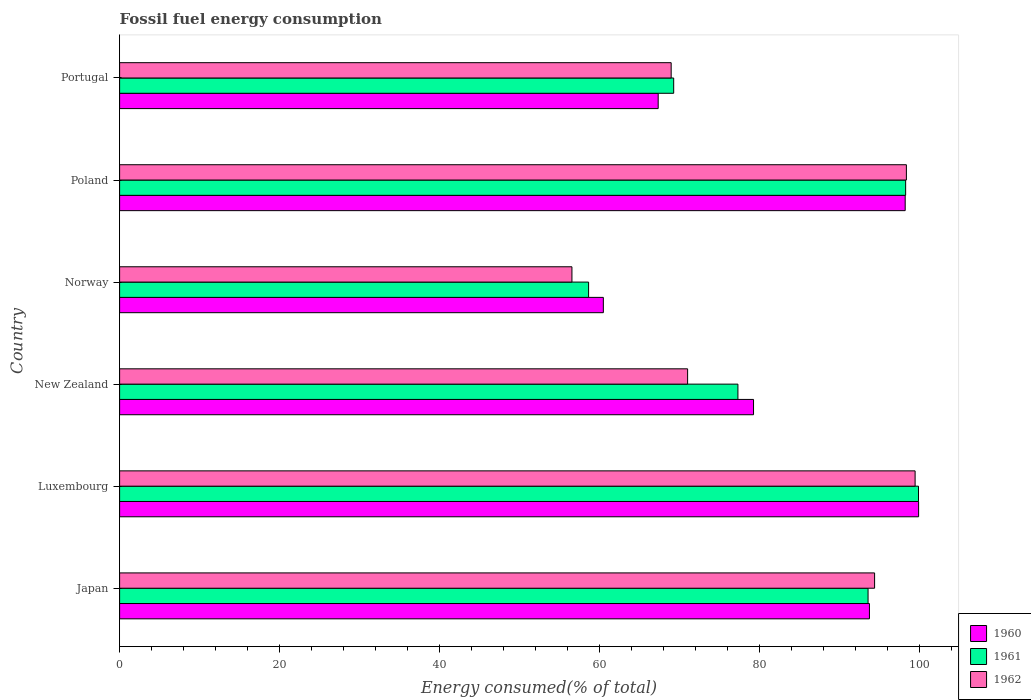How many groups of bars are there?
Offer a terse response. 6. Are the number of bars on each tick of the Y-axis equal?
Offer a terse response. Yes. How many bars are there on the 1st tick from the top?
Ensure brevity in your answer.  3. What is the label of the 1st group of bars from the top?
Your response must be concise. Portugal. What is the percentage of energy consumed in 1961 in Luxembourg?
Ensure brevity in your answer.  99.91. Across all countries, what is the maximum percentage of energy consumed in 1962?
Offer a terse response. 99.49. Across all countries, what is the minimum percentage of energy consumed in 1961?
Offer a very short reply. 58.65. In which country was the percentage of energy consumed in 1962 maximum?
Your response must be concise. Luxembourg. What is the total percentage of energy consumed in 1962 in the graph?
Make the answer very short. 488.89. What is the difference between the percentage of energy consumed in 1960 in Japan and that in Norway?
Offer a terse response. 33.28. What is the difference between the percentage of energy consumed in 1962 in New Zealand and the percentage of energy consumed in 1961 in Poland?
Provide a succinct answer. -27.27. What is the average percentage of energy consumed in 1962 per country?
Give a very brief answer. 81.48. What is the difference between the percentage of energy consumed in 1961 and percentage of energy consumed in 1960 in Portugal?
Your response must be concise. 1.94. In how many countries, is the percentage of energy consumed in 1961 greater than 16 %?
Provide a succinct answer. 6. What is the ratio of the percentage of energy consumed in 1960 in New Zealand to that in Norway?
Offer a very short reply. 1.31. Is the percentage of energy consumed in 1960 in New Zealand less than that in Poland?
Ensure brevity in your answer.  Yes. What is the difference between the highest and the second highest percentage of energy consumed in 1962?
Your answer should be compact. 1.09. What is the difference between the highest and the lowest percentage of energy consumed in 1960?
Your answer should be compact. 39.43. In how many countries, is the percentage of energy consumed in 1961 greater than the average percentage of energy consumed in 1961 taken over all countries?
Ensure brevity in your answer.  3. Is the sum of the percentage of energy consumed in 1960 in Japan and Portugal greater than the maximum percentage of energy consumed in 1962 across all countries?
Your answer should be compact. Yes. What does the 2nd bar from the top in Japan represents?
Keep it short and to the point. 1961. How many countries are there in the graph?
Ensure brevity in your answer.  6. Does the graph contain any zero values?
Offer a terse response. No. Does the graph contain grids?
Your answer should be very brief. No. How many legend labels are there?
Provide a short and direct response. 3. What is the title of the graph?
Your response must be concise. Fossil fuel energy consumption. What is the label or title of the X-axis?
Provide a short and direct response. Energy consumed(% of total). What is the Energy consumed(% of total) in 1960 in Japan?
Your answer should be very brief. 93.78. What is the Energy consumed(% of total) in 1961 in Japan?
Make the answer very short. 93.6. What is the Energy consumed(% of total) in 1962 in Japan?
Ensure brevity in your answer.  94.42. What is the Energy consumed(% of total) of 1960 in Luxembourg?
Ensure brevity in your answer.  99.92. What is the Energy consumed(% of total) in 1961 in Luxembourg?
Your response must be concise. 99.91. What is the Energy consumed(% of total) in 1962 in Luxembourg?
Make the answer very short. 99.49. What is the Energy consumed(% of total) in 1960 in New Zealand?
Offer a terse response. 79.28. What is the Energy consumed(% of total) of 1961 in New Zealand?
Offer a terse response. 77.33. What is the Energy consumed(% of total) in 1962 in New Zealand?
Provide a succinct answer. 71.04. What is the Energy consumed(% of total) of 1960 in Norway?
Ensure brevity in your answer.  60.5. What is the Energy consumed(% of total) of 1961 in Norway?
Provide a succinct answer. 58.65. What is the Energy consumed(% of total) in 1962 in Norway?
Give a very brief answer. 56.57. What is the Energy consumed(% of total) in 1960 in Poland?
Your answer should be very brief. 98.25. What is the Energy consumed(% of total) of 1961 in Poland?
Your answer should be compact. 98.3. What is the Energy consumed(% of total) of 1962 in Poland?
Offer a very short reply. 98.4. What is the Energy consumed(% of total) of 1960 in Portugal?
Provide a short and direct response. 67.36. What is the Energy consumed(% of total) in 1961 in Portugal?
Make the answer very short. 69.3. What is the Energy consumed(% of total) in 1962 in Portugal?
Give a very brief answer. 68.98. Across all countries, what is the maximum Energy consumed(% of total) in 1960?
Provide a succinct answer. 99.92. Across all countries, what is the maximum Energy consumed(% of total) in 1961?
Make the answer very short. 99.91. Across all countries, what is the maximum Energy consumed(% of total) of 1962?
Keep it short and to the point. 99.49. Across all countries, what is the minimum Energy consumed(% of total) of 1960?
Ensure brevity in your answer.  60.5. Across all countries, what is the minimum Energy consumed(% of total) in 1961?
Your response must be concise. 58.65. Across all countries, what is the minimum Energy consumed(% of total) in 1962?
Offer a very short reply. 56.57. What is the total Energy consumed(% of total) in 1960 in the graph?
Keep it short and to the point. 499.08. What is the total Energy consumed(% of total) of 1961 in the graph?
Give a very brief answer. 497.09. What is the total Energy consumed(% of total) of 1962 in the graph?
Provide a succinct answer. 488.89. What is the difference between the Energy consumed(% of total) of 1960 in Japan and that in Luxembourg?
Make the answer very short. -6.15. What is the difference between the Energy consumed(% of total) in 1961 in Japan and that in Luxembourg?
Offer a terse response. -6.31. What is the difference between the Energy consumed(% of total) of 1962 in Japan and that in Luxembourg?
Provide a short and direct response. -5.07. What is the difference between the Energy consumed(% of total) of 1960 in Japan and that in New Zealand?
Make the answer very short. 14.5. What is the difference between the Energy consumed(% of total) in 1961 in Japan and that in New Zealand?
Ensure brevity in your answer.  16.28. What is the difference between the Energy consumed(% of total) in 1962 in Japan and that in New Zealand?
Your answer should be compact. 23.38. What is the difference between the Energy consumed(% of total) of 1960 in Japan and that in Norway?
Your answer should be compact. 33.28. What is the difference between the Energy consumed(% of total) in 1961 in Japan and that in Norway?
Make the answer very short. 34.95. What is the difference between the Energy consumed(% of total) in 1962 in Japan and that in Norway?
Provide a short and direct response. 37.85. What is the difference between the Energy consumed(% of total) of 1960 in Japan and that in Poland?
Ensure brevity in your answer.  -4.47. What is the difference between the Energy consumed(% of total) in 1961 in Japan and that in Poland?
Your answer should be very brief. -4.7. What is the difference between the Energy consumed(% of total) of 1962 in Japan and that in Poland?
Your response must be concise. -3.98. What is the difference between the Energy consumed(% of total) in 1960 in Japan and that in Portugal?
Offer a terse response. 26.42. What is the difference between the Energy consumed(% of total) of 1961 in Japan and that in Portugal?
Provide a short and direct response. 24.31. What is the difference between the Energy consumed(% of total) of 1962 in Japan and that in Portugal?
Offer a very short reply. 25.44. What is the difference between the Energy consumed(% of total) of 1960 in Luxembourg and that in New Zealand?
Keep it short and to the point. 20.65. What is the difference between the Energy consumed(% of total) of 1961 in Luxembourg and that in New Zealand?
Your answer should be very brief. 22.58. What is the difference between the Energy consumed(% of total) of 1962 in Luxembourg and that in New Zealand?
Your response must be concise. 28.45. What is the difference between the Energy consumed(% of total) of 1960 in Luxembourg and that in Norway?
Make the answer very short. 39.43. What is the difference between the Energy consumed(% of total) of 1961 in Luxembourg and that in Norway?
Provide a succinct answer. 41.26. What is the difference between the Energy consumed(% of total) in 1962 in Luxembourg and that in Norway?
Keep it short and to the point. 42.92. What is the difference between the Energy consumed(% of total) in 1960 in Luxembourg and that in Poland?
Ensure brevity in your answer.  1.68. What is the difference between the Energy consumed(% of total) in 1961 in Luxembourg and that in Poland?
Ensure brevity in your answer.  1.61. What is the difference between the Energy consumed(% of total) of 1962 in Luxembourg and that in Poland?
Ensure brevity in your answer.  1.09. What is the difference between the Energy consumed(% of total) of 1960 in Luxembourg and that in Portugal?
Make the answer very short. 32.57. What is the difference between the Energy consumed(% of total) in 1961 in Luxembourg and that in Portugal?
Keep it short and to the point. 30.62. What is the difference between the Energy consumed(% of total) in 1962 in Luxembourg and that in Portugal?
Give a very brief answer. 30.51. What is the difference between the Energy consumed(% of total) of 1960 in New Zealand and that in Norway?
Your answer should be very brief. 18.78. What is the difference between the Energy consumed(% of total) in 1961 in New Zealand and that in Norway?
Keep it short and to the point. 18.68. What is the difference between the Energy consumed(% of total) of 1962 in New Zealand and that in Norway?
Ensure brevity in your answer.  14.47. What is the difference between the Energy consumed(% of total) in 1960 in New Zealand and that in Poland?
Your answer should be very brief. -18.97. What is the difference between the Energy consumed(% of total) of 1961 in New Zealand and that in Poland?
Ensure brevity in your answer.  -20.98. What is the difference between the Energy consumed(% of total) in 1962 in New Zealand and that in Poland?
Offer a terse response. -27.36. What is the difference between the Energy consumed(% of total) in 1960 in New Zealand and that in Portugal?
Make the answer very short. 11.92. What is the difference between the Energy consumed(% of total) of 1961 in New Zealand and that in Portugal?
Your answer should be very brief. 8.03. What is the difference between the Energy consumed(% of total) in 1962 in New Zealand and that in Portugal?
Your response must be concise. 2.06. What is the difference between the Energy consumed(% of total) in 1960 in Norway and that in Poland?
Provide a short and direct response. -37.75. What is the difference between the Energy consumed(% of total) in 1961 in Norway and that in Poland?
Provide a succinct answer. -39.65. What is the difference between the Energy consumed(% of total) in 1962 in Norway and that in Poland?
Your answer should be compact. -41.83. What is the difference between the Energy consumed(% of total) of 1960 in Norway and that in Portugal?
Offer a very short reply. -6.86. What is the difference between the Energy consumed(% of total) of 1961 in Norway and that in Portugal?
Provide a short and direct response. -10.64. What is the difference between the Energy consumed(% of total) of 1962 in Norway and that in Portugal?
Offer a very short reply. -12.41. What is the difference between the Energy consumed(% of total) of 1960 in Poland and that in Portugal?
Your answer should be very brief. 30.89. What is the difference between the Energy consumed(% of total) in 1961 in Poland and that in Portugal?
Provide a short and direct response. 29.01. What is the difference between the Energy consumed(% of total) in 1962 in Poland and that in Portugal?
Offer a very short reply. 29.42. What is the difference between the Energy consumed(% of total) of 1960 in Japan and the Energy consumed(% of total) of 1961 in Luxembourg?
Your answer should be compact. -6.14. What is the difference between the Energy consumed(% of total) of 1960 in Japan and the Energy consumed(% of total) of 1962 in Luxembourg?
Your answer should be compact. -5.71. What is the difference between the Energy consumed(% of total) of 1961 in Japan and the Energy consumed(% of total) of 1962 in Luxembourg?
Offer a terse response. -5.88. What is the difference between the Energy consumed(% of total) of 1960 in Japan and the Energy consumed(% of total) of 1961 in New Zealand?
Give a very brief answer. 16.45. What is the difference between the Energy consumed(% of total) in 1960 in Japan and the Energy consumed(% of total) in 1962 in New Zealand?
Give a very brief answer. 22.74. What is the difference between the Energy consumed(% of total) in 1961 in Japan and the Energy consumed(% of total) in 1962 in New Zealand?
Your answer should be compact. 22.57. What is the difference between the Energy consumed(% of total) of 1960 in Japan and the Energy consumed(% of total) of 1961 in Norway?
Offer a very short reply. 35.12. What is the difference between the Energy consumed(% of total) of 1960 in Japan and the Energy consumed(% of total) of 1962 in Norway?
Provide a short and direct response. 37.21. What is the difference between the Energy consumed(% of total) in 1961 in Japan and the Energy consumed(% of total) in 1962 in Norway?
Offer a terse response. 37.03. What is the difference between the Energy consumed(% of total) of 1960 in Japan and the Energy consumed(% of total) of 1961 in Poland?
Give a very brief answer. -4.53. What is the difference between the Energy consumed(% of total) of 1960 in Japan and the Energy consumed(% of total) of 1962 in Poland?
Give a very brief answer. -4.62. What is the difference between the Energy consumed(% of total) of 1961 in Japan and the Energy consumed(% of total) of 1962 in Poland?
Your answer should be very brief. -4.79. What is the difference between the Energy consumed(% of total) of 1960 in Japan and the Energy consumed(% of total) of 1961 in Portugal?
Offer a very short reply. 24.48. What is the difference between the Energy consumed(% of total) in 1960 in Japan and the Energy consumed(% of total) in 1962 in Portugal?
Your response must be concise. 24.8. What is the difference between the Energy consumed(% of total) of 1961 in Japan and the Energy consumed(% of total) of 1962 in Portugal?
Your response must be concise. 24.62. What is the difference between the Energy consumed(% of total) of 1960 in Luxembourg and the Energy consumed(% of total) of 1961 in New Zealand?
Your answer should be compact. 22.6. What is the difference between the Energy consumed(% of total) of 1960 in Luxembourg and the Energy consumed(% of total) of 1962 in New Zealand?
Your answer should be very brief. 28.89. What is the difference between the Energy consumed(% of total) of 1961 in Luxembourg and the Energy consumed(% of total) of 1962 in New Zealand?
Ensure brevity in your answer.  28.88. What is the difference between the Energy consumed(% of total) of 1960 in Luxembourg and the Energy consumed(% of total) of 1961 in Norway?
Keep it short and to the point. 41.27. What is the difference between the Energy consumed(% of total) in 1960 in Luxembourg and the Energy consumed(% of total) in 1962 in Norway?
Keep it short and to the point. 43.35. What is the difference between the Energy consumed(% of total) of 1961 in Luxembourg and the Energy consumed(% of total) of 1962 in Norway?
Keep it short and to the point. 43.34. What is the difference between the Energy consumed(% of total) of 1960 in Luxembourg and the Energy consumed(% of total) of 1961 in Poland?
Provide a short and direct response. 1.62. What is the difference between the Energy consumed(% of total) of 1960 in Luxembourg and the Energy consumed(% of total) of 1962 in Poland?
Ensure brevity in your answer.  1.53. What is the difference between the Energy consumed(% of total) in 1961 in Luxembourg and the Energy consumed(% of total) in 1962 in Poland?
Offer a terse response. 1.52. What is the difference between the Energy consumed(% of total) of 1960 in Luxembourg and the Energy consumed(% of total) of 1961 in Portugal?
Provide a succinct answer. 30.63. What is the difference between the Energy consumed(% of total) in 1960 in Luxembourg and the Energy consumed(% of total) in 1962 in Portugal?
Provide a succinct answer. 30.95. What is the difference between the Energy consumed(% of total) of 1961 in Luxembourg and the Energy consumed(% of total) of 1962 in Portugal?
Provide a succinct answer. 30.93. What is the difference between the Energy consumed(% of total) in 1960 in New Zealand and the Energy consumed(% of total) in 1961 in Norway?
Make the answer very short. 20.63. What is the difference between the Energy consumed(% of total) of 1960 in New Zealand and the Energy consumed(% of total) of 1962 in Norway?
Offer a terse response. 22.71. What is the difference between the Energy consumed(% of total) in 1961 in New Zealand and the Energy consumed(% of total) in 1962 in Norway?
Keep it short and to the point. 20.76. What is the difference between the Energy consumed(% of total) of 1960 in New Zealand and the Energy consumed(% of total) of 1961 in Poland?
Keep it short and to the point. -19.02. What is the difference between the Energy consumed(% of total) of 1960 in New Zealand and the Energy consumed(% of total) of 1962 in Poland?
Make the answer very short. -19.12. What is the difference between the Energy consumed(% of total) of 1961 in New Zealand and the Energy consumed(% of total) of 1962 in Poland?
Ensure brevity in your answer.  -21.07. What is the difference between the Energy consumed(% of total) of 1960 in New Zealand and the Energy consumed(% of total) of 1961 in Portugal?
Offer a terse response. 9.98. What is the difference between the Energy consumed(% of total) of 1960 in New Zealand and the Energy consumed(% of total) of 1962 in Portugal?
Keep it short and to the point. 10.3. What is the difference between the Energy consumed(% of total) of 1961 in New Zealand and the Energy consumed(% of total) of 1962 in Portugal?
Offer a terse response. 8.35. What is the difference between the Energy consumed(% of total) of 1960 in Norway and the Energy consumed(% of total) of 1961 in Poland?
Provide a succinct answer. -37.81. What is the difference between the Energy consumed(% of total) in 1960 in Norway and the Energy consumed(% of total) in 1962 in Poland?
Offer a very short reply. -37.9. What is the difference between the Energy consumed(% of total) of 1961 in Norway and the Energy consumed(% of total) of 1962 in Poland?
Provide a succinct answer. -39.74. What is the difference between the Energy consumed(% of total) of 1960 in Norway and the Energy consumed(% of total) of 1961 in Portugal?
Keep it short and to the point. -8.8. What is the difference between the Energy consumed(% of total) in 1960 in Norway and the Energy consumed(% of total) in 1962 in Portugal?
Your answer should be very brief. -8.48. What is the difference between the Energy consumed(% of total) of 1961 in Norway and the Energy consumed(% of total) of 1962 in Portugal?
Provide a succinct answer. -10.33. What is the difference between the Energy consumed(% of total) in 1960 in Poland and the Energy consumed(% of total) in 1961 in Portugal?
Offer a terse response. 28.95. What is the difference between the Energy consumed(% of total) in 1960 in Poland and the Energy consumed(% of total) in 1962 in Portugal?
Make the answer very short. 29.27. What is the difference between the Energy consumed(% of total) in 1961 in Poland and the Energy consumed(% of total) in 1962 in Portugal?
Make the answer very short. 29.32. What is the average Energy consumed(% of total) in 1960 per country?
Keep it short and to the point. 83.18. What is the average Energy consumed(% of total) of 1961 per country?
Give a very brief answer. 82.85. What is the average Energy consumed(% of total) of 1962 per country?
Your answer should be very brief. 81.48. What is the difference between the Energy consumed(% of total) in 1960 and Energy consumed(% of total) in 1961 in Japan?
Give a very brief answer. 0.17. What is the difference between the Energy consumed(% of total) in 1960 and Energy consumed(% of total) in 1962 in Japan?
Your response must be concise. -0.64. What is the difference between the Energy consumed(% of total) of 1961 and Energy consumed(% of total) of 1962 in Japan?
Offer a very short reply. -0.82. What is the difference between the Energy consumed(% of total) in 1960 and Energy consumed(% of total) in 1961 in Luxembourg?
Provide a short and direct response. 0.01. What is the difference between the Energy consumed(% of total) of 1960 and Energy consumed(% of total) of 1962 in Luxembourg?
Your answer should be compact. 0.44. What is the difference between the Energy consumed(% of total) of 1961 and Energy consumed(% of total) of 1962 in Luxembourg?
Offer a very short reply. 0.42. What is the difference between the Energy consumed(% of total) in 1960 and Energy consumed(% of total) in 1961 in New Zealand?
Keep it short and to the point. 1.95. What is the difference between the Energy consumed(% of total) in 1960 and Energy consumed(% of total) in 1962 in New Zealand?
Provide a succinct answer. 8.24. What is the difference between the Energy consumed(% of total) of 1961 and Energy consumed(% of total) of 1962 in New Zealand?
Your answer should be very brief. 6.29. What is the difference between the Energy consumed(% of total) of 1960 and Energy consumed(% of total) of 1961 in Norway?
Offer a very short reply. 1.85. What is the difference between the Energy consumed(% of total) of 1960 and Energy consumed(% of total) of 1962 in Norway?
Offer a very short reply. 3.93. What is the difference between the Energy consumed(% of total) in 1961 and Energy consumed(% of total) in 1962 in Norway?
Offer a terse response. 2.08. What is the difference between the Energy consumed(% of total) of 1960 and Energy consumed(% of total) of 1961 in Poland?
Offer a terse response. -0.06. What is the difference between the Energy consumed(% of total) of 1960 and Energy consumed(% of total) of 1962 in Poland?
Ensure brevity in your answer.  -0.15. What is the difference between the Energy consumed(% of total) of 1961 and Energy consumed(% of total) of 1962 in Poland?
Provide a succinct answer. -0.09. What is the difference between the Energy consumed(% of total) of 1960 and Energy consumed(% of total) of 1961 in Portugal?
Offer a very short reply. -1.94. What is the difference between the Energy consumed(% of total) in 1960 and Energy consumed(% of total) in 1962 in Portugal?
Keep it short and to the point. -1.62. What is the difference between the Energy consumed(% of total) of 1961 and Energy consumed(% of total) of 1962 in Portugal?
Give a very brief answer. 0.32. What is the ratio of the Energy consumed(% of total) in 1960 in Japan to that in Luxembourg?
Your answer should be very brief. 0.94. What is the ratio of the Energy consumed(% of total) of 1961 in Japan to that in Luxembourg?
Keep it short and to the point. 0.94. What is the ratio of the Energy consumed(% of total) in 1962 in Japan to that in Luxembourg?
Keep it short and to the point. 0.95. What is the ratio of the Energy consumed(% of total) of 1960 in Japan to that in New Zealand?
Your answer should be compact. 1.18. What is the ratio of the Energy consumed(% of total) of 1961 in Japan to that in New Zealand?
Provide a short and direct response. 1.21. What is the ratio of the Energy consumed(% of total) in 1962 in Japan to that in New Zealand?
Provide a short and direct response. 1.33. What is the ratio of the Energy consumed(% of total) in 1960 in Japan to that in Norway?
Offer a very short reply. 1.55. What is the ratio of the Energy consumed(% of total) of 1961 in Japan to that in Norway?
Provide a short and direct response. 1.6. What is the ratio of the Energy consumed(% of total) in 1962 in Japan to that in Norway?
Give a very brief answer. 1.67. What is the ratio of the Energy consumed(% of total) in 1960 in Japan to that in Poland?
Your response must be concise. 0.95. What is the ratio of the Energy consumed(% of total) of 1961 in Japan to that in Poland?
Your answer should be compact. 0.95. What is the ratio of the Energy consumed(% of total) of 1962 in Japan to that in Poland?
Your answer should be very brief. 0.96. What is the ratio of the Energy consumed(% of total) of 1960 in Japan to that in Portugal?
Offer a very short reply. 1.39. What is the ratio of the Energy consumed(% of total) of 1961 in Japan to that in Portugal?
Offer a very short reply. 1.35. What is the ratio of the Energy consumed(% of total) in 1962 in Japan to that in Portugal?
Your answer should be very brief. 1.37. What is the ratio of the Energy consumed(% of total) in 1960 in Luxembourg to that in New Zealand?
Give a very brief answer. 1.26. What is the ratio of the Energy consumed(% of total) of 1961 in Luxembourg to that in New Zealand?
Give a very brief answer. 1.29. What is the ratio of the Energy consumed(% of total) in 1962 in Luxembourg to that in New Zealand?
Keep it short and to the point. 1.4. What is the ratio of the Energy consumed(% of total) in 1960 in Luxembourg to that in Norway?
Your answer should be compact. 1.65. What is the ratio of the Energy consumed(% of total) in 1961 in Luxembourg to that in Norway?
Your answer should be compact. 1.7. What is the ratio of the Energy consumed(% of total) in 1962 in Luxembourg to that in Norway?
Offer a very short reply. 1.76. What is the ratio of the Energy consumed(% of total) of 1960 in Luxembourg to that in Poland?
Offer a terse response. 1.02. What is the ratio of the Energy consumed(% of total) in 1961 in Luxembourg to that in Poland?
Provide a short and direct response. 1.02. What is the ratio of the Energy consumed(% of total) in 1962 in Luxembourg to that in Poland?
Keep it short and to the point. 1.01. What is the ratio of the Energy consumed(% of total) in 1960 in Luxembourg to that in Portugal?
Keep it short and to the point. 1.48. What is the ratio of the Energy consumed(% of total) in 1961 in Luxembourg to that in Portugal?
Offer a very short reply. 1.44. What is the ratio of the Energy consumed(% of total) of 1962 in Luxembourg to that in Portugal?
Make the answer very short. 1.44. What is the ratio of the Energy consumed(% of total) in 1960 in New Zealand to that in Norway?
Your response must be concise. 1.31. What is the ratio of the Energy consumed(% of total) of 1961 in New Zealand to that in Norway?
Give a very brief answer. 1.32. What is the ratio of the Energy consumed(% of total) in 1962 in New Zealand to that in Norway?
Keep it short and to the point. 1.26. What is the ratio of the Energy consumed(% of total) in 1960 in New Zealand to that in Poland?
Your response must be concise. 0.81. What is the ratio of the Energy consumed(% of total) in 1961 in New Zealand to that in Poland?
Your answer should be very brief. 0.79. What is the ratio of the Energy consumed(% of total) in 1962 in New Zealand to that in Poland?
Provide a succinct answer. 0.72. What is the ratio of the Energy consumed(% of total) in 1960 in New Zealand to that in Portugal?
Provide a short and direct response. 1.18. What is the ratio of the Energy consumed(% of total) of 1961 in New Zealand to that in Portugal?
Make the answer very short. 1.12. What is the ratio of the Energy consumed(% of total) of 1962 in New Zealand to that in Portugal?
Make the answer very short. 1.03. What is the ratio of the Energy consumed(% of total) of 1960 in Norway to that in Poland?
Offer a terse response. 0.62. What is the ratio of the Energy consumed(% of total) of 1961 in Norway to that in Poland?
Provide a short and direct response. 0.6. What is the ratio of the Energy consumed(% of total) of 1962 in Norway to that in Poland?
Keep it short and to the point. 0.57. What is the ratio of the Energy consumed(% of total) of 1960 in Norway to that in Portugal?
Make the answer very short. 0.9. What is the ratio of the Energy consumed(% of total) in 1961 in Norway to that in Portugal?
Provide a succinct answer. 0.85. What is the ratio of the Energy consumed(% of total) in 1962 in Norway to that in Portugal?
Keep it short and to the point. 0.82. What is the ratio of the Energy consumed(% of total) of 1960 in Poland to that in Portugal?
Provide a short and direct response. 1.46. What is the ratio of the Energy consumed(% of total) in 1961 in Poland to that in Portugal?
Your response must be concise. 1.42. What is the ratio of the Energy consumed(% of total) in 1962 in Poland to that in Portugal?
Give a very brief answer. 1.43. What is the difference between the highest and the second highest Energy consumed(% of total) of 1960?
Your response must be concise. 1.68. What is the difference between the highest and the second highest Energy consumed(% of total) in 1961?
Your response must be concise. 1.61. What is the difference between the highest and the second highest Energy consumed(% of total) in 1962?
Make the answer very short. 1.09. What is the difference between the highest and the lowest Energy consumed(% of total) of 1960?
Your answer should be very brief. 39.43. What is the difference between the highest and the lowest Energy consumed(% of total) of 1961?
Provide a succinct answer. 41.26. What is the difference between the highest and the lowest Energy consumed(% of total) of 1962?
Make the answer very short. 42.92. 